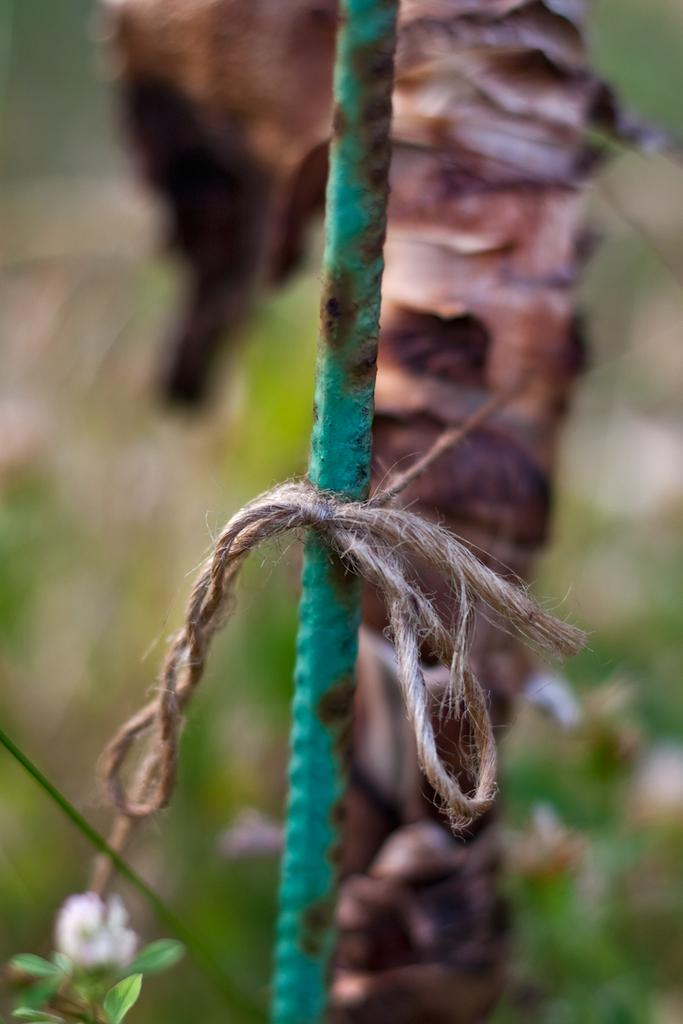What is connected to the rod in the image? There is a rope tied to a rod in the image. What type of plant can be seen in the image? There is a plant with a flower in the image. How would you describe the background of the image? The background of the image is blurred. What can be seen in the background of the image? Objects are visible in the background of the image. How many rabbits are hopping on the hill in the image? There are no rabbits or hills present in the image. What type of locket is hanging from the flower in the image? There is no locket present in the image; it only features a plant with a flower. 